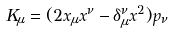Convert formula to latex. <formula><loc_0><loc_0><loc_500><loc_500>K _ { \mu } = ( 2 x _ { \mu } x ^ { \nu } - \delta _ { \mu } ^ { \nu } x ^ { 2 } ) p _ { \nu }</formula> 